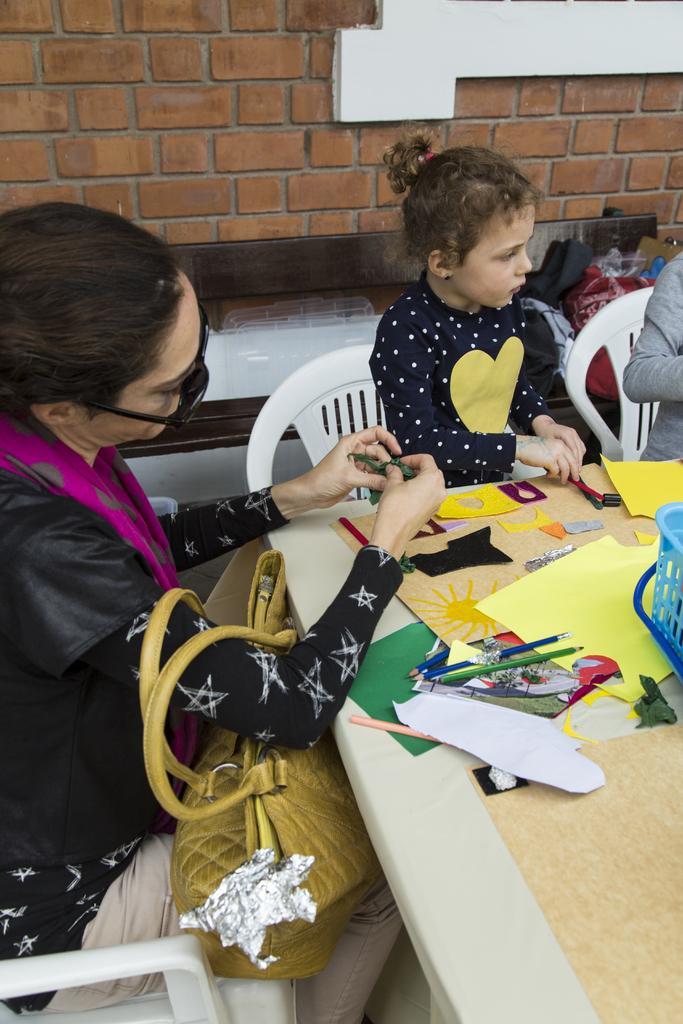In one or two sentences, can you explain what this image depicts? In this image I can see a woman and girl sitting on the chair. The woman is holding a handbag. On the table there are pencils,basket and a chart papers. At the back side there is a building. 